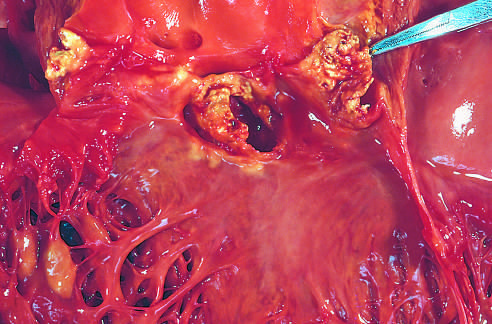how is acute endocarditis caused?
Answer the question using a single word or phrase. By staphylococcus aureus on a congenitally bicuspid aortic valve with extensive cuspal destruction and ring abscess 